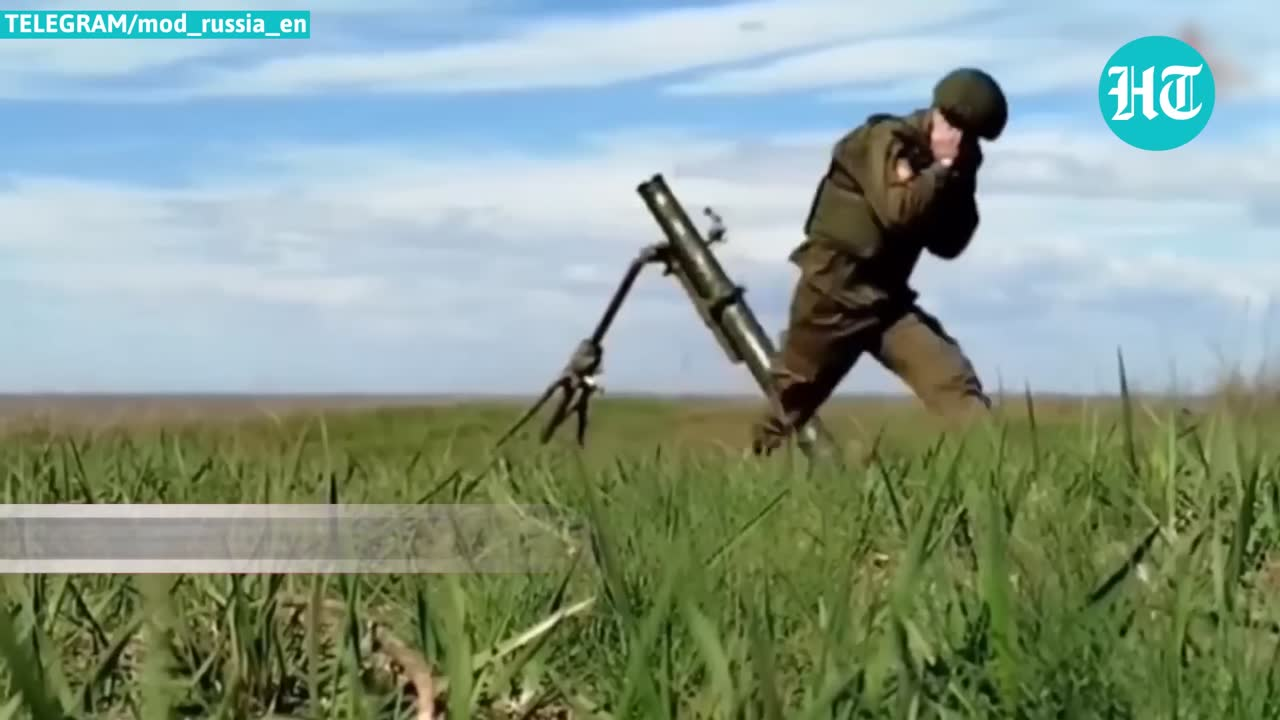list out what objects  this img show The image shows the following objects:

1. Soldier in military uniform
2. Helmet
3. Mortar (a type of artillery)
4. Backpack or military gear on the soldier
5. Grass and vegetation
6. Sky with clouds

The image also includes some text and a logo in the upper corners. 